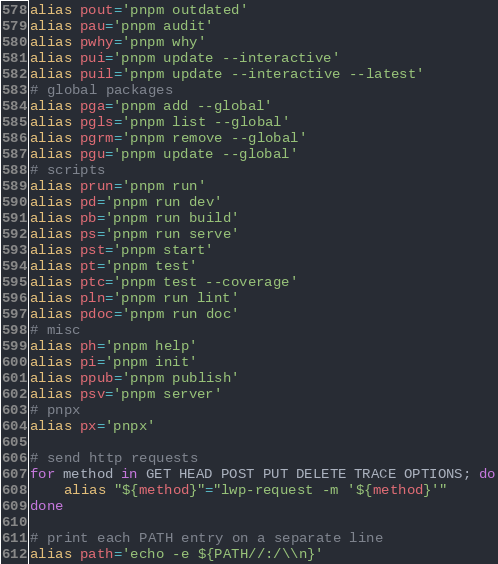<code> <loc_0><loc_0><loc_500><loc_500><_Bash_>alias pout='pnpm outdated'
alias pau='pnpm audit'
alias pwhy='pnpm why'
alias pui='pnpm update --interactive'
alias puil='pnpm update --interactive --latest'
# global packages
alias pga='pnpm add --global'
alias pgls='pnpm list --global'
alias pgrm='pnpm remove --global'
alias pgu='pnpm update --global'
# scripts
alias prun='pnpm run'
alias pd='pnpm run dev'
alias pb='pnpm run build'
alias ps='pnpm run serve'
alias pst='pnpm start'
alias pt='pnpm test'
alias ptc='pnpm test --coverage'
alias pln='pnpm run lint'
alias pdoc='pnpm run doc'
# misc
alias ph='pnpm help'
alias pi='pnpm init'
alias ppub='pnpm publish'
alias psv='pnpm server'
# pnpx
alias px='pnpx'

# send http requests
for method in GET HEAD POST PUT DELETE TRACE OPTIONS; do
	alias "${method}"="lwp-request -m '${method}'"
done

# print each PATH entry on a separate line
alias path='echo -e ${PATH//:/\\n}'</code> 